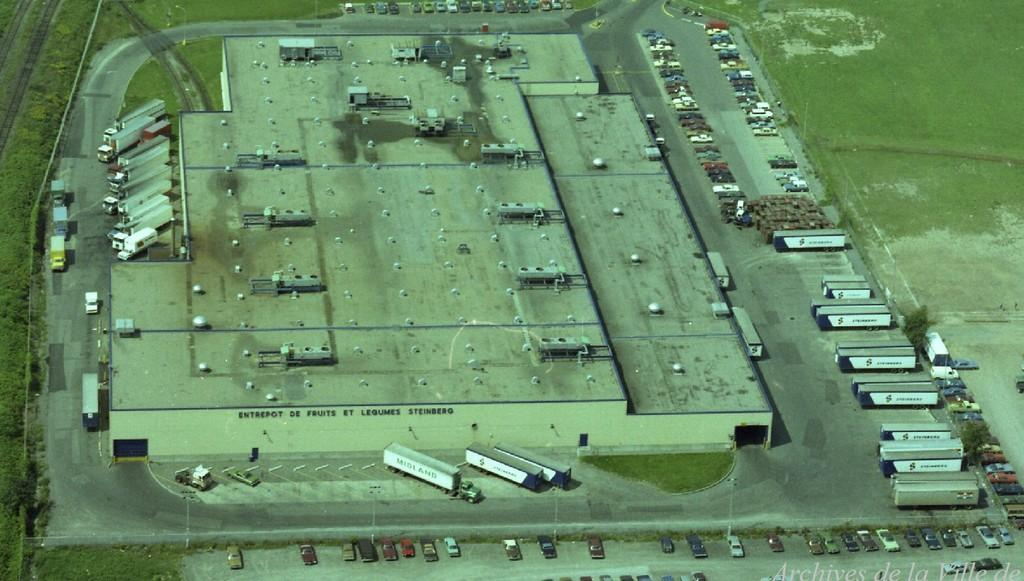What can be seen in the image that is used for transportation? There is a group of vehicles in the image. What type of structures are present in the image? There are sheds in the image. What is on the ground in the image? There are objects on the ground in the image. What type of natural vegetation is visible in the image? Trees are visible in the image. Where can text be found in the image? Text is present in the bottom right corner of the image. How much does the snail weigh in the image? There is no snail present in the image, so its weight cannot be determined. What type of stretch is visible in the image? There is no stretch visible in the image; it features a group of vehicles, sheds, objects on the ground, trees, and text. 